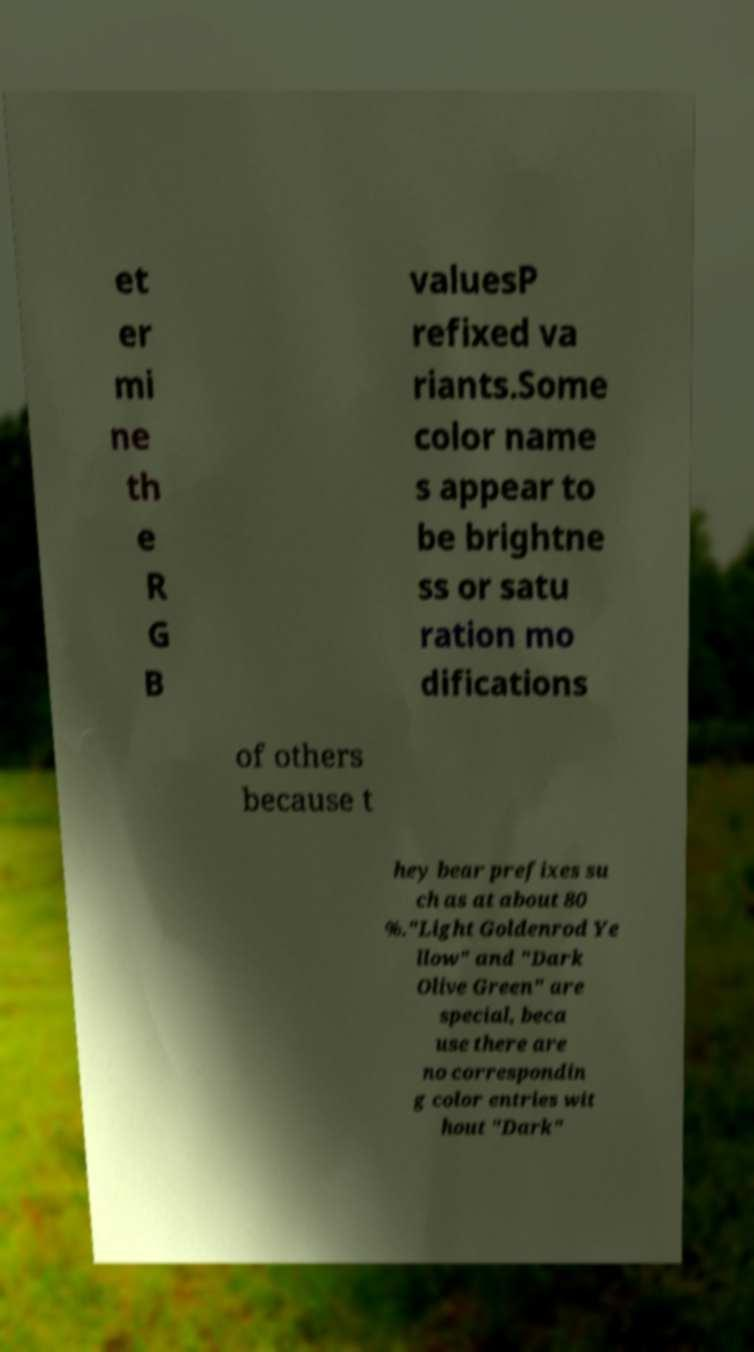Please read and relay the text visible in this image. What does it say? et er mi ne th e R G B valuesP refixed va riants.Some color name s appear to be brightne ss or satu ration mo difications of others because t hey bear prefixes su ch as at about 80 %."Light Goldenrod Ye llow" and "Dark Olive Green" are special, beca use there are no correspondin g color entries wit hout "Dark" 